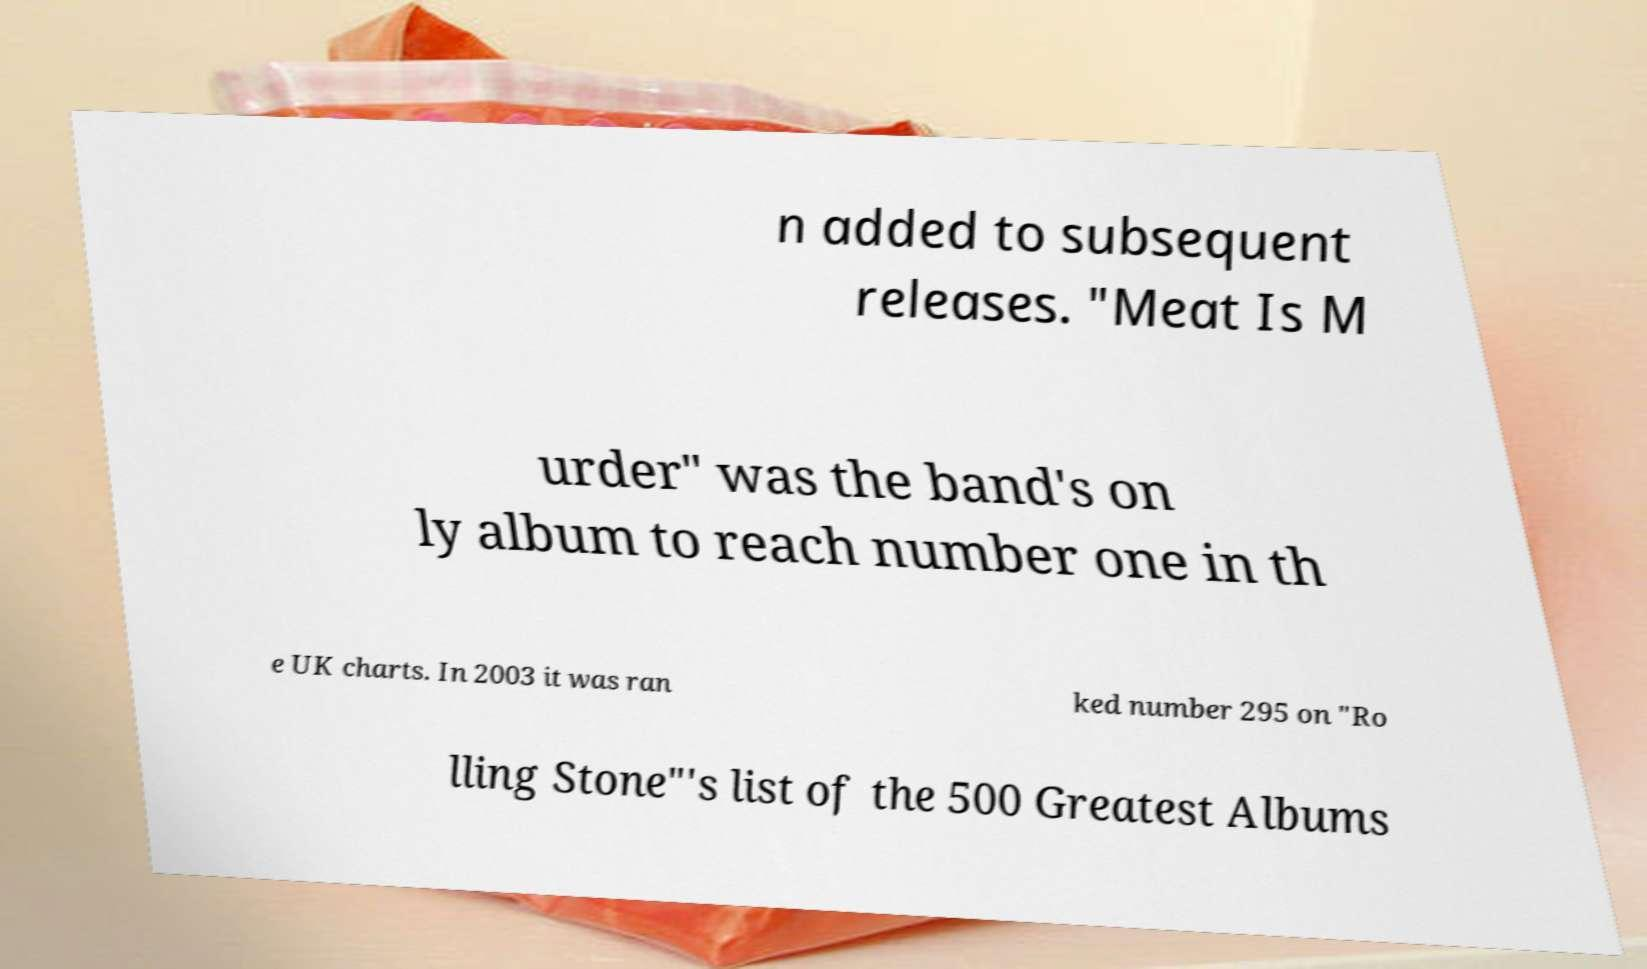For documentation purposes, I need the text within this image transcribed. Could you provide that? n added to subsequent releases. "Meat Is M urder" was the band's on ly album to reach number one in th e UK charts. In 2003 it was ran ked number 295 on "Ro lling Stone"'s list of the 500 Greatest Albums 